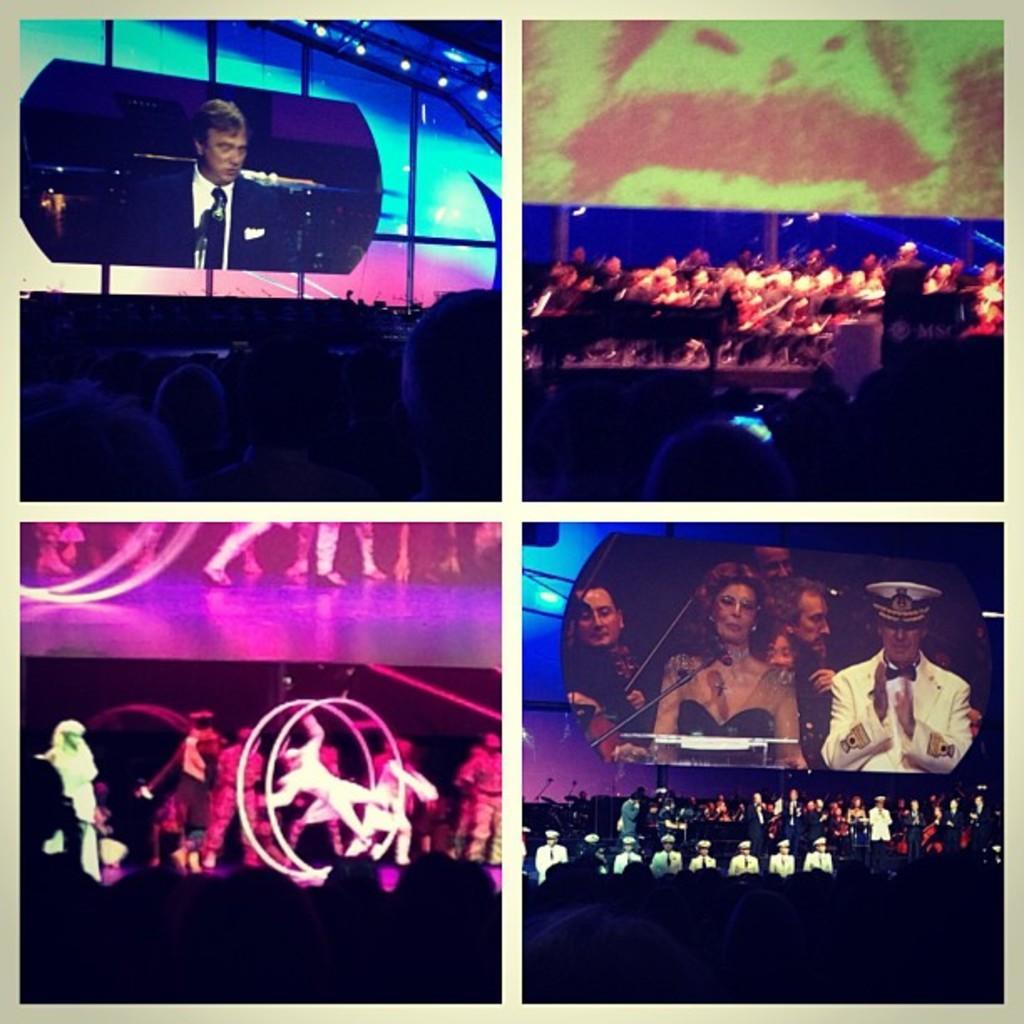In one or two sentences, can you explain what this image depicts? This is a collage picture. Here we can see a screen and a person talking on the mike. There are few persons on the stage. Here we can see crowd and few persons on the screen. 